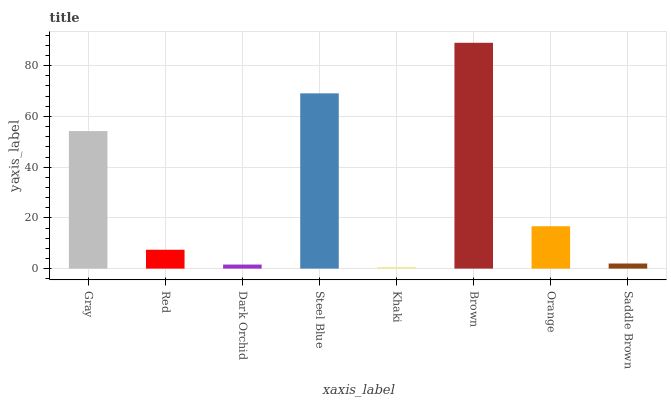Is Khaki the minimum?
Answer yes or no. Yes. Is Brown the maximum?
Answer yes or no. Yes. Is Red the minimum?
Answer yes or no. No. Is Red the maximum?
Answer yes or no. No. Is Gray greater than Red?
Answer yes or no. Yes. Is Red less than Gray?
Answer yes or no. Yes. Is Red greater than Gray?
Answer yes or no. No. Is Gray less than Red?
Answer yes or no. No. Is Orange the high median?
Answer yes or no. Yes. Is Red the low median?
Answer yes or no. Yes. Is Saddle Brown the high median?
Answer yes or no. No. Is Gray the low median?
Answer yes or no. No. 